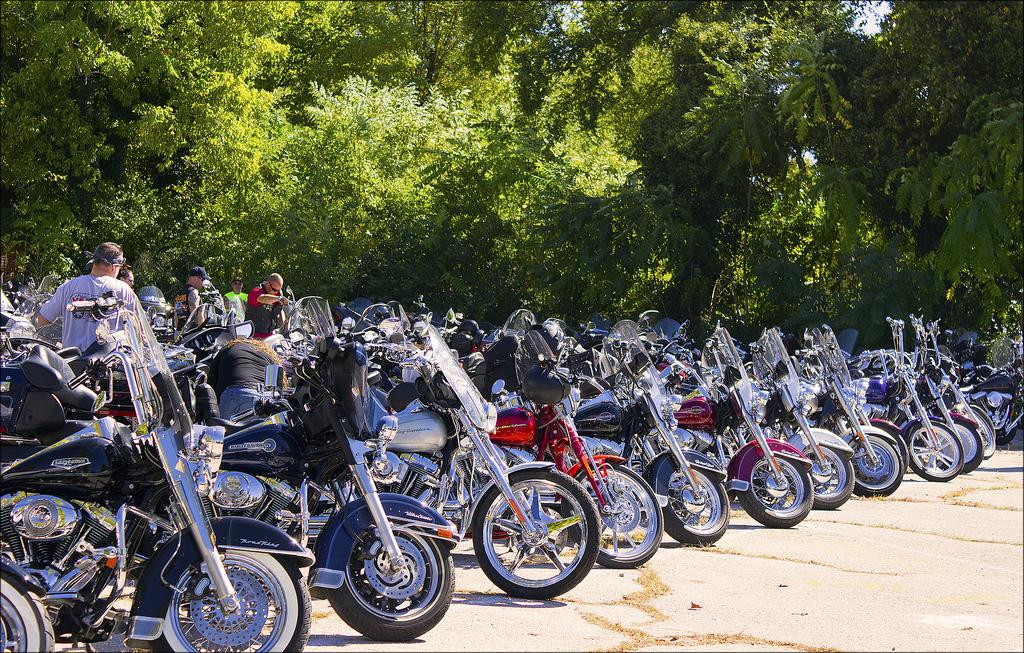Using metaphor, explain the overall scene captured in the image. A parade of metallic horses adorned with intricate details, basking under the shade of nature's green canopy, as onlookers observe their beauty. In the form of a haiku, describe the scene depicted in the image. People gaze, admire. Write a single sentence that paints a vivid scene, combining the most significant aspects of the image. Under the azure canopy of the sky, a row of gleaming motorcycles, embraced by verdant trees, creates a mesmerizing spectacle for the diverse gathering of admirers. Provide a concise summary of the prominent elements in the image. The image features a row of shiny motorcycles, green leaves on trees, and people observing the bikes with different clothing styles. Provide a short, descriptive phrase summarizing the picture's main focus. A harmonious blend of gleaming motorcycles, nature's green touch, and diverse spectators. Imagine you're describing the image for a radio broadcast. What are the three main visual elements you can note? There's an impressive row of shiny motorcycles, a background of trees with green leaves, and a group of onlookers dressed in various outfits. Write a brief sentence about the image's primary focus and secondary elements. A line of gleaming motorcycles catches the eye, while leafy trees and spectators in various attire complement the scene. Describe the key elements in the image in the style of a news headline. Motorcycle Show Attracts Diverse Crowd Amidst Lush Greenery Using a simile, describe the main subject found in the image. A row of shiny motorcycles, lined up like polished gems, draws attention from several onlookers and lush green trees framing the scene. Imagine you are describing the image to someone who can't see it; briefly elaborate on the main subjects in the picture. Picture a row of shiny bikes under a clear sky, parked near trees with green leaves, as people wearing different shirts and vests gather around to admire them. 